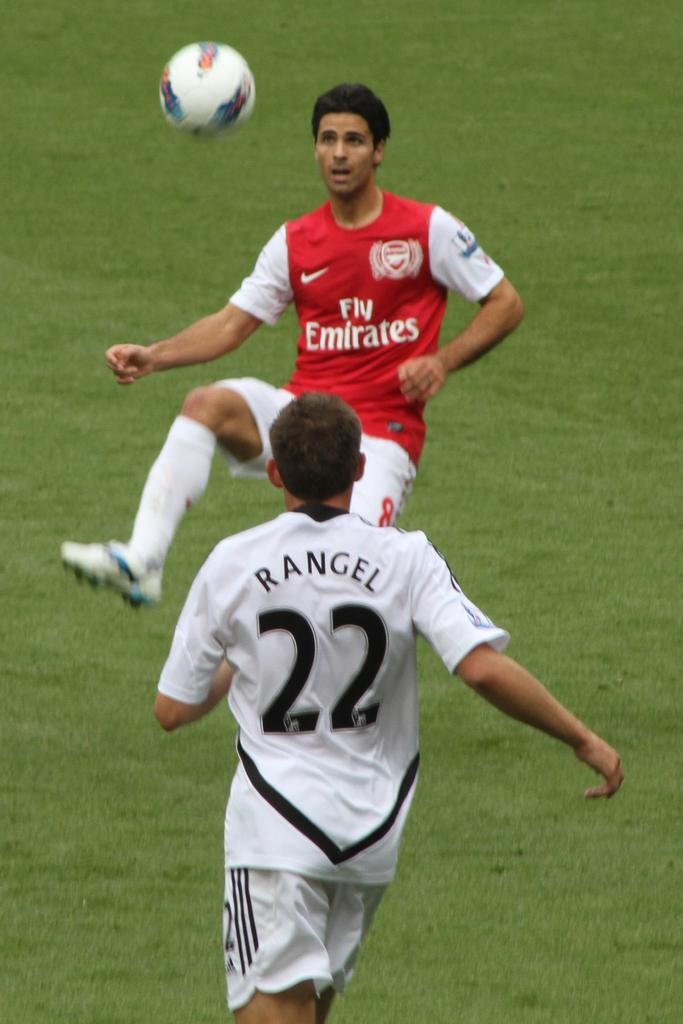<image>
Present a compact description of the photo's key features. An Emirates soccer player with a lifted leg is in front of the ball in the air. 